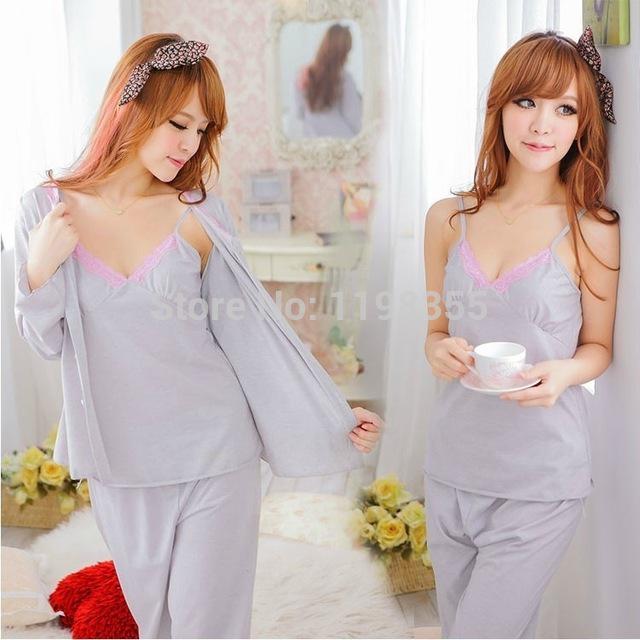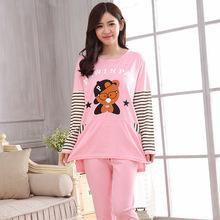The first image is the image on the left, the second image is the image on the right. Considering the images on both sides, is "The right image contains a lady wearing pajamas featuring a large teddy bear, not a frog, with a window and a couch in the background." valid? Answer yes or no. Yes. The first image is the image on the left, the second image is the image on the right. Analyze the images presented: Is the assertion "One image shows a model in pink loungewear featuring a face on it." valid? Answer yes or no. Yes. 